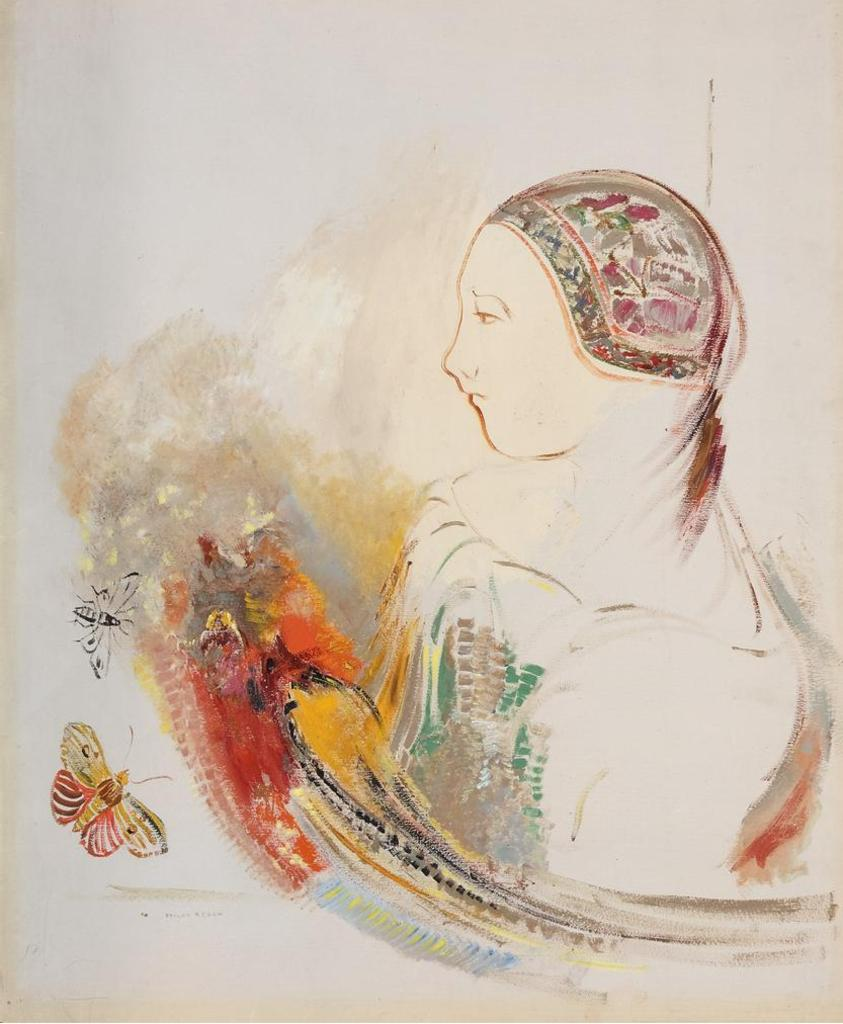What subjects are depicted in the paintings in the image? There is a painting of a person and a painting of butterflies in the image. What is the color of the background in the image? The background of the image is white in color. Can you see a cat playing with a flame in the image? There is no cat or flame present in the image. 